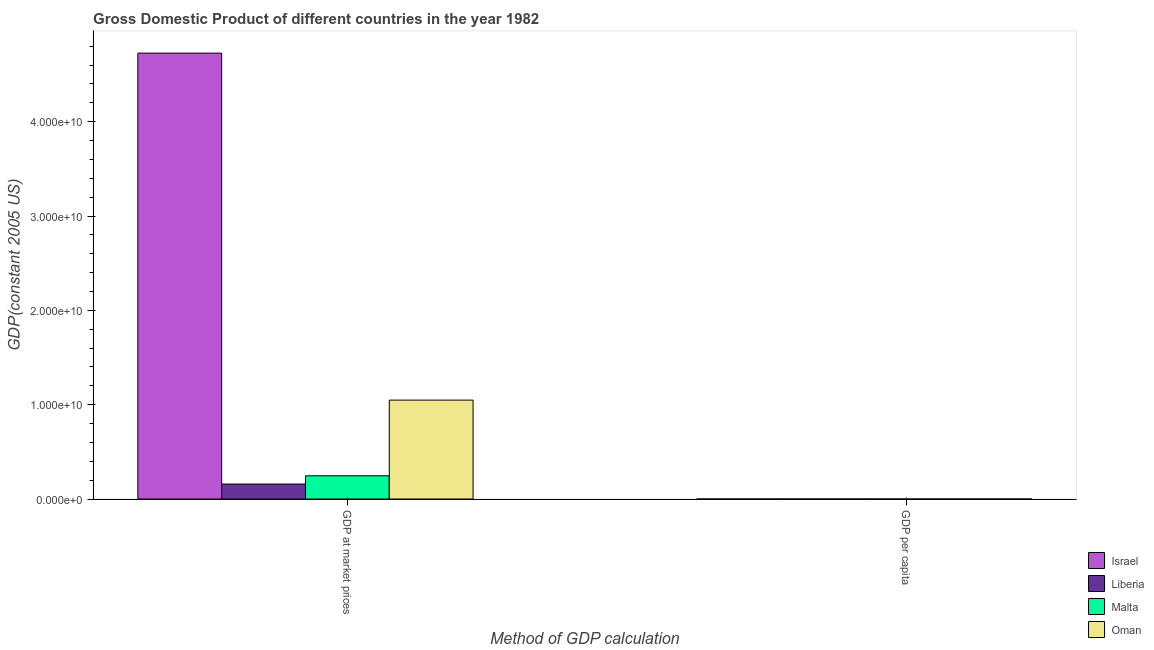How many different coloured bars are there?
Keep it short and to the point. 4. How many groups of bars are there?
Your answer should be very brief. 2. Are the number of bars per tick equal to the number of legend labels?
Make the answer very short. Yes. Are the number of bars on each tick of the X-axis equal?
Your response must be concise. Yes. What is the label of the 1st group of bars from the left?
Keep it short and to the point. GDP at market prices. What is the gdp per capita in Malta?
Your answer should be compact. 7558.35. Across all countries, what is the maximum gdp at market prices?
Make the answer very short. 4.73e+1. Across all countries, what is the minimum gdp per capita?
Offer a very short reply. 779.79. In which country was the gdp at market prices minimum?
Your response must be concise. Liberia. What is the total gdp per capita in the graph?
Provide a short and direct response. 2.82e+04. What is the difference between the gdp per capita in Liberia and that in Israel?
Provide a succinct answer. -1.09e+04. What is the difference between the gdp at market prices in Israel and the gdp per capita in Liberia?
Provide a succinct answer. 4.73e+1. What is the average gdp per capita per country?
Offer a terse response. 7047.74. What is the difference between the gdp at market prices and gdp per capita in Israel?
Provide a short and direct response. 4.73e+1. In how many countries, is the gdp at market prices greater than 28000000000 US$?
Keep it short and to the point. 1. What is the ratio of the gdp at market prices in Malta to that in Liberia?
Your answer should be very brief. 1.55. In how many countries, is the gdp per capita greater than the average gdp per capita taken over all countries?
Your answer should be compact. 3. What does the 3rd bar from the left in GDP at market prices represents?
Give a very brief answer. Malta. What does the 3rd bar from the right in GDP per capita represents?
Make the answer very short. Liberia. Are all the bars in the graph horizontal?
Make the answer very short. No. Are the values on the major ticks of Y-axis written in scientific E-notation?
Your answer should be compact. Yes. Where does the legend appear in the graph?
Offer a terse response. Bottom right. How are the legend labels stacked?
Your answer should be very brief. Vertical. What is the title of the graph?
Provide a succinct answer. Gross Domestic Product of different countries in the year 1982. What is the label or title of the X-axis?
Provide a succinct answer. Method of GDP calculation. What is the label or title of the Y-axis?
Your answer should be very brief. GDP(constant 2005 US). What is the GDP(constant 2005 US) of Israel in GDP at market prices?
Your response must be concise. 4.73e+1. What is the GDP(constant 2005 US) of Liberia in GDP at market prices?
Your answer should be very brief. 1.59e+09. What is the GDP(constant 2005 US) of Malta in GDP at market prices?
Ensure brevity in your answer.  2.46e+09. What is the GDP(constant 2005 US) of Oman in GDP at market prices?
Provide a short and direct response. 1.05e+1. What is the GDP(constant 2005 US) in Israel in GDP per capita?
Offer a terse response. 1.17e+04. What is the GDP(constant 2005 US) of Liberia in GDP per capita?
Provide a succinct answer. 779.79. What is the GDP(constant 2005 US) in Malta in GDP per capita?
Your response must be concise. 7558.35. What is the GDP(constant 2005 US) of Oman in GDP per capita?
Your answer should be compact. 8127.1. Across all Method of GDP calculation, what is the maximum GDP(constant 2005 US) in Israel?
Your answer should be compact. 4.73e+1. Across all Method of GDP calculation, what is the maximum GDP(constant 2005 US) of Liberia?
Your answer should be very brief. 1.59e+09. Across all Method of GDP calculation, what is the maximum GDP(constant 2005 US) in Malta?
Your response must be concise. 2.46e+09. Across all Method of GDP calculation, what is the maximum GDP(constant 2005 US) in Oman?
Your answer should be very brief. 1.05e+1. Across all Method of GDP calculation, what is the minimum GDP(constant 2005 US) in Israel?
Make the answer very short. 1.17e+04. Across all Method of GDP calculation, what is the minimum GDP(constant 2005 US) of Liberia?
Your response must be concise. 779.79. Across all Method of GDP calculation, what is the minimum GDP(constant 2005 US) of Malta?
Provide a succinct answer. 7558.35. Across all Method of GDP calculation, what is the minimum GDP(constant 2005 US) of Oman?
Your answer should be very brief. 8127.1. What is the total GDP(constant 2005 US) of Israel in the graph?
Keep it short and to the point. 4.73e+1. What is the total GDP(constant 2005 US) in Liberia in the graph?
Offer a very short reply. 1.59e+09. What is the total GDP(constant 2005 US) of Malta in the graph?
Offer a very short reply. 2.46e+09. What is the total GDP(constant 2005 US) of Oman in the graph?
Offer a very short reply. 1.05e+1. What is the difference between the GDP(constant 2005 US) of Israel in GDP at market prices and that in GDP per capita?
Offer a very short reply. 4.73e+1. What is the difference between the GDP(constant 2005 US) in Liberia in GDP at market prices and that in GDP per capita?
Offer a terse response. 1.59e+09. What is the difference between the GDP(constant 2005 US) in Malta in GDP at market prices and that in GDP per capita?
Keep it short and to the point. 2.46e+09. What is the difference between the GDP(constant 2005 US) of Oman in GDP at market prices and that in GDP per capita?
Offer a terse response. 1.05e+1. What is the difference between the GDP(constant 2005 US) in Israel in GDP at market prices and the GDP(constant 2005 US) in Liberia in GDP per capita?
Keep it short and to the point. 4.73e+1. What is the difference between the GDP(constant 2005 US) in Israel in GDP at market prices and the GDP(constant 2005 US) in Malta in GDP per capita?
Give a very brief answer. 4.73e+1. What is the difference between the GDP(constant 2005 US) in Israel in GDP at market prices and the GDP(constant 2005 US) in Oman in GDP per capita?
Give a very brief answer. 4.73e+1. What is the difference between the GDP(constant 2005 US) in Liberia in GDP at market prices and the GDP(constant 2005 US) in Malta in GDP per capita?
Your answer should be compact. 1.59e+09. What is the difference between the GDP(constant 2005 US) in Liberia in GDP at market prices and the GDP(constant 2005 US) in Oman in GDP per capita?
Provide a succinct answer. 1.59e+09. What is the difference between the GDP(constant 2005 US) in Malta in GDP at market prices and the GDP(constant 2005 US) in Oman in GDP per capita?
Your answer should be very brief. 2.46e+09. What is the average GDP(constant 2005 US) of Israel per Method of GDP calculation?
Offer a very short reply. 2.36e+1. What is the average GDP(constant 2005 US) in Liberia per Method of GDP calculation?
Your response must be concise. 7.94e+08. What is the average GDP(constant 2005 US) of Malta per Method of GDP calculation?
Offer a terse response. 1.23e+09. What is the average GDP(constant 2005 US) in Oman per Method of GDP calculation?
Provide a short and direct response. 5.24e+09. What is the difference between the GDP(constant 2005 US) in Israel and GDP(constant 2005 US) in Liberia in GDP at market prices?
Make the answer very short. 4.57e+1. What is the difference between the GDP(constant 2005 US) in Israel and GDP(constant 2005 US) in Malta in GDP at market prices?
Offer a very short reply. 4.48e+1. What is the difference between the GDP(constant 2005 US) of Israel and GDP(constant 2005 US) of Oman in GDP at market prices?
Your answer should be compact. 3.68e+1. What is the difference between the GDP(constant 2005 US) in Liberia and GDP(constant 2005 US) in Malta in GDP at market prices?
Keep it short and to the point. -8.75e+08. What is the difference between the GDP(constant 2005 US) of Liberia and GDP(constant 2005 US) of Oman in GDP at market prices?
Provide a short and direct response. -8.90e+09. What is the difference between the GDP(constant 2005 US) of Malta and GDP(constant 2005 US) of Oman in GDP at market prices?
Offer a terse response. -8.02e+09. What is the difference between the GDP(constant 2005 US) of Israel and GDP(constant 2005 US) of Liberia in GDP per capita?
Your answer should be compact. 1.09e+04. What is the difference between the GDP(constant 2005 US) in Israel and GDP(constant 2005 US) in Malta in GDP per capita?
Give a very brief answer. 4167.37. What is the difference between the GDP(constant 2005 US) of Israel and GDP(constant 2005 US) of Oman in GDP per capita?
Make the answer very short. 3598.62. What is the difference between the GDP(constant 2005 US) of Liberia and GDP(constant 2005 US) of Malta in GDP per capita?
Provide a short and direct response. -6778.56. What is the difference between the GDP(constant 2005 US) in Liberia and GDP(constant 2005 US) in Oman in GDP per capita?
Your answer should be very brief. -7347.3. What is the difference between the GDP(constant 2005 US) in Malta and GDP(constant 2005 US) in Oman in GDP per capita?
Provide a short and direct response. -568.75. What is the ratio of the GDP(constant 2005 US) in Israel in GDP at market prices to that in GDP per capita?
Keep it short and to the point. 4.03e+06. What is the ratio of the GDP(constant 2005 US) in Liberia in GDP at market prices to that in GDP per capita?
Provide a short and direct response. 2.04e+06. What is the ratio of the GDP(constant 2005 US) of Malta in GDP at market prices to that in GDP per capita?
Offer a terse response. 3.26e+05. What is the ratio of the GDP(constant 2005 US) of Oman in GDP at market prices to that in GDP per capita?
Give a very brief answer. 1.29e+06. What is the difference between the highest and the second highest GDP(constant 2005 US) of Israel?
Offer a very short reply. 4.73e+1. What is the difference between the highest and the second highest GDP(constant 2005 US) in Liberia?
Your answer should be very brief. 1.59e+09. What is the difference between the highest and the second highest GDP(constant 2005 US) of Malta?
Your answer should be very brief. 2.46e+09. What is the difference between the highest and the second highest GDP(constant 2005 US) of Oman?
Offer a very short reply. 1.05e+1. What is the difference between the highest and the lowest GDP(constant 2005 US) in Israel?
Offer a terse response. 4.73e+1. What is the difference between the highest and the lowest GDP(constant 2005 US) of Liberia?
Provide a short and direct response. 1.59e+09. What is the difference between the highest and the lowest GDP(constant 2005 US) of Malta?
Your response must be concise. 2.46e+09. What is the difference between the highest and the lowest GDP(constant 2005 US) in Oman?
Offer a very short reply. 1.05e+1. 